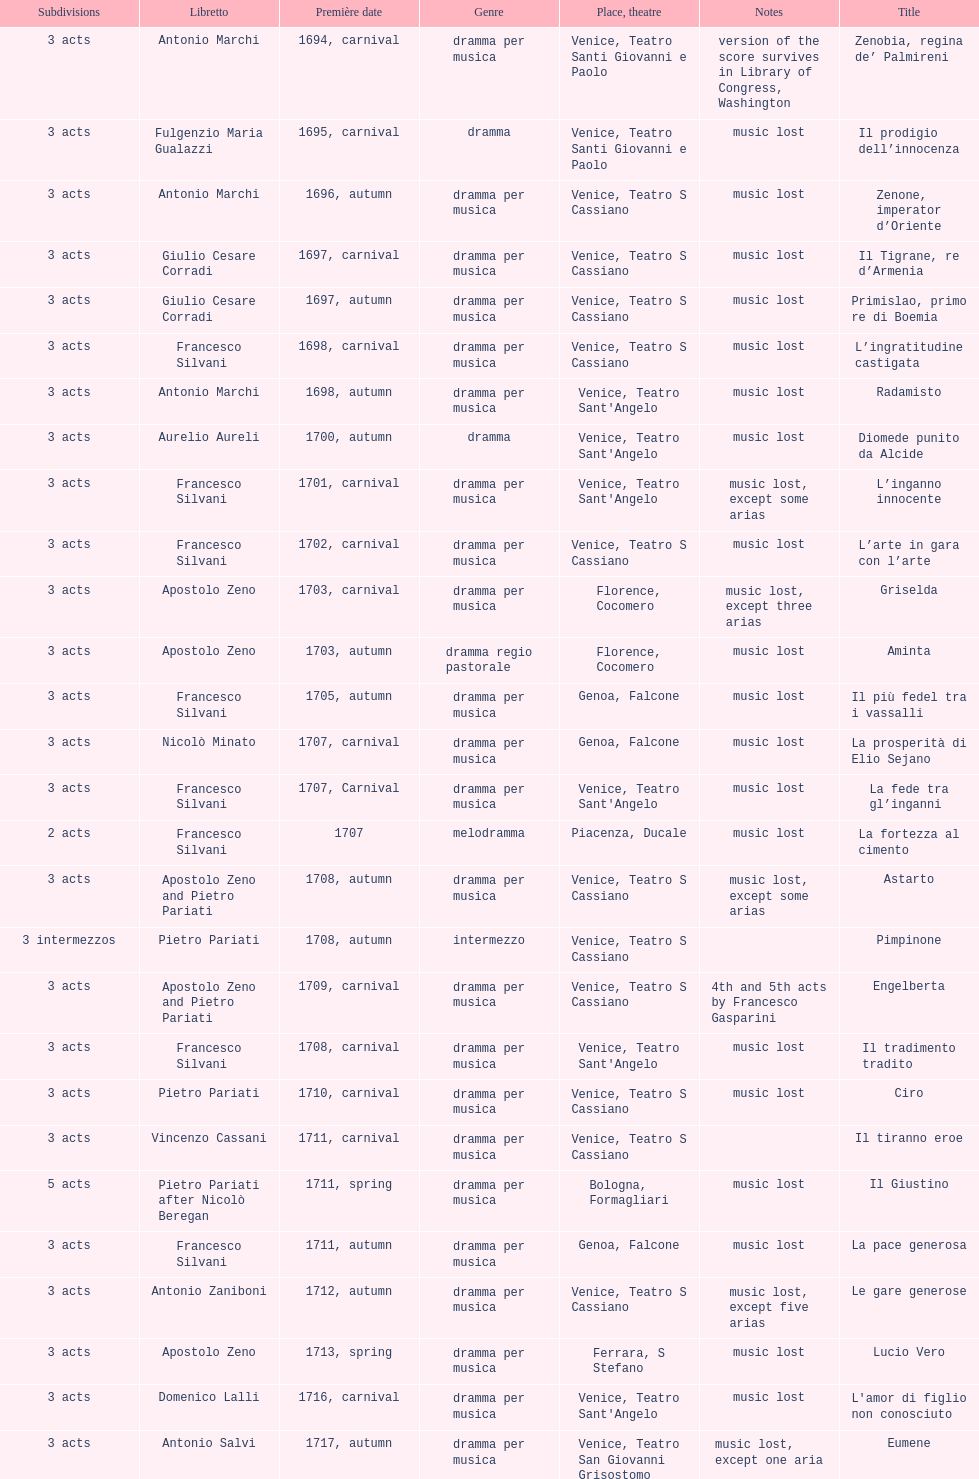What number of acts does il giustino have? 5. Could you parse the entire table as a dict? {'header': ['Sub\xaddivisions', 'Libretto', 'Première date', 'Genre', 'Place, theatre', 'Notes', 'Title'], 'rows': [['3 acts', 'Antonio Marchi', '1694, carnival', 'dramma per musica', 'Venice, Teatro Santi Giovanni e Paolo', 'version of the score survives in Library of Congress, Washington', 'Zenobia, regina de’ Palmireni'], ['3 acts', 'Fulgenzio Maria Gualazzi', '1695, carnival', 'dramma', 'Venice, Teatro Santi Giovanni e Paolo', 'music lost', 'Il prodigio dell’innocenza'], ['3 acts', 'Antonio Marchi', '1696, autumn', 'dramma per musica', 'Venice, Teatro S Cassiano', 'music lost', 'Zenone, imperator d’Oriente'], ['3 acts', 'Giulio Cesare Corradi', '1697, carnival', 'dramma per musica', 'Venice, Teatro S Cassiano', 'music lost', 'Il Tigrane, re d’Armenia'], ['3 acts', 'Giulio Cesare Corradi', '1697, autumn', 'dramma per musica', 'Venice, Teatro S Cassiano', 'music lost', 'Primislao, primo re di Boemia'], ['3 acts', 'Francesco Silvani', '1698, carnival', 'dramma per musica', 'Venice, Teatro S Cassiano', 'music lost', 'L’ingratitudine castigata'], ['3 acts', 'Antonio Marchi', '1698, autumn', 'dramma per musica', "Venice, Teatro Sant'Angelo", 'music lost', 'Radamisto'], ['3 acts', 'Aurelio Aureli', '1700, autumn', 'dramma', "Venice, Teatro Sant'Angelo", 'music lost', 'Diomede punito da Alcide'], ['3 acts', 'Francesco Silvani', '1701, carnival', 'dramma per musica', "Venice, Teatro Sant'Angelo", 'music lost, except some arias', 'L’inganno innocente'], ['3 acts', 'Francesco Silvani', '1702, carnival', 'dramma per musica', 'Venice, Teatro S Cassiano', 'music lost', 'L’arte in gara con l’arte'], ['3 acts', 'Apostolo Zeno', '1703, carnival', 'dramma per musica', 'Florence, Cocomero', 'music lost, except three arias', 'Griselda'], ['3 acts', 'Apostolo Zeno', '1703, autumn', 'dramma regio pastorale', 'Florence, Cocomero', 'music lost', 'Aminta'], ['3 acts', 'Francesco Silvani', '1705, autumn', 'dramma per musica', 'Genoa, Falcone', 'music lost', 'Il più fedel tra i vassalli'], ['3 acts', 'Nicolò Minato', '1707, carnival', 'dramma per musica', 'Genoa, Falcone', 'music lost', 'La prosperità di Elio Sejano'], ['3 acts', 'Francesco Silvani', '1707, Carnival', 'dramma per musica', "Venice, Teatro Sant'Angelo", 'music lost', 'La fede tra gl’inganni'], ['2 acts', 'Francesco Silvani', '1707', 'melodramma', 'Piacenza, Ducale', 'music lost', 'La fortezza al cimento'], ['3 acts', 'Apostolo Zeno and Pietro Pariati', '1708, autumn', 'dramma per musica', 'Venice, Teatro S Cassiano', 'music lost, except some arias', 'Astarto'], ['3 intermezzos', 'Pietro Pariati', '1708, autumn', 'intermezzo', 'Venice, Teatro S Cassiano', '', 'Pimpinone'], ['3 acts', 'Apostolo Zeno and Pietro Pariati', '1709, carnival', 'dramma per musica', 'Venice, Teatro S Cassiano', '4th and 5th acts by Francesco Gasparini', 'Engelberta'], ['3 acts', 'Francesco Silvani', '1708, carnival', 'dramma per musica', "Venice, Teatro Sant'Angelo", 'music lost', 'Il tradimento tradito'], ['3 acts', 'Pietro Pariati', '1710, carnival', 'dramma per musica', 'Venice, Teatro S Cassiano', 'music lost', 'Ciro'], ['3 acts', 'Vincenzo Cassani', '1711, carnival', 'dramma per musica', 'Venice, Teatro S Cassiano', '', 'Il tiranno eroe'], ['5 acts', 'Pietro Pariati after Nicolò Beregan', '1711, spring', 'dramma per musica', 'Bologna, Formagliari', 'music lost', 'Il Giustino'], ['3 acts', 'Francesco Silvani', '1711, autumn', 'dramma per musica', 'Genoa, Falcone', 'music lost', 'La pace generosa'], ['3 acts', 'Antonio Zaniboni', '1712, autumn', 'dramma per musica', 'Venice, Teatro S Cassiano', 'music lost, except five arias', 'Le gare generose'], ['3 acts', 'Apostolo Zeno', '1713, spring', 'dramma per musica', 'Ferrara, S Stefano', 'music lost', 'Lucio Vero'], ['3 acts', 'Domenico Lalli', '1716, carnival', 'dramma per musica', "Venice, Teatro Sant'Angelo", 'music lost', "L'amor di figlio non conosciuto"], ['3 acts', 'Antonio Salvi', '1717, autumn', 'dramma per musica', 'Venice, Teatro San Giovanni Grisostomo', 'music lost, except one aria', 'Eumene'], ['3 acts', 'Pietro Antonio Bernardoni', '1718, carnival', 'dramma per musica', "Venice, Teatro Sant'Angelo", 'music lost', 'Meleagro'], ['3 acts', 'Vincenzo Cassani', '1718, carnival', 'dramma per musica', "Venice, Teatro Sant'Angelo", 'music lost', 'Cleomene'], ['3 acts', 'Domenico Lalli', '1722, carnival', 'dramma per musica', "Venice, Teatro Sant'Angelo", 'music lost, except some arias', 'Gli eccessi della gelosia'], ['3 acts', 'Francesco Silvani and Domenico Lalli after Pierre Corneille', '1722, October', 'dramma per musica', 'Munich, Hof', 'music lost, except some arias', 'I veri amici'], ['3 acts', 'Pietro Pariati', '1722, November', 'dramma per musica', 'Munich', 'music lost', 'Il trionfo d’amore'], ['3 acts', 'Apostolo Zeno', '1723, carnival', 'dramma per musica', 'Venice, Teatro San Moisè', 'music lost, except 2 arias', 'Eumene'], ['3 acts', 'Antonio Maria Lucchini', '1723, autumn', 'dramma per musica', 'Venice, Teatro San Moisè', 'music lost', 'Ermengarda'], ['5 acts', 'Giovanni Piazzon', '1724, carnival', 'tragedia', 'Venice, Teatro San Moisè', '5th act by Giovanni Porta, music lost', 'Antigono, tutore di Filippo, re di Macedonia'], ['3 acts', 'Apostolo Zeno', '1724, Ascension', 'dramma per musica', 'Venice, Teatro San Samuele', 'music lost', 'Scipione nelle Spagne'], ['3 acts', 'Angelo Schietti', '1724, autumn', 'dramma per musica', 'Venice, Teatro San Moisè', 'music lost, except 2 arias', 'Laodice'], ['3 acts', 'Metastasio', '1725, carnival', 'tragedia', 'Venice, Teatro S Cassiano', 'music lost', 'Didone abbandonata'], ['2 acts', 'Metastasio', '1725, carnival', 'intermezzo', 'Venice, Teatro S Cassiano', 'music lost', "L'impresario delle Isole Canarie"], ['3 acts', 'Antonio Marchi', '1725, autumn', 'dramma per musica', 'Venice, Teatro S Cassiano', 'music lost', 'Alcina delusa da Ruggero'], ['3 acts', 'Apostolo Zeno', '1725', 'dramma per musica', 'Brescia, Nuovo', '', 'I rivali generosi'], ['3 acts', 'Apostolo Zeno and Pietro Pariati', '1726, Carnival', 'dramma per musica', 'Rome, Teatro Capranica', '', 'La Statira'], ['', '', '1726, Carnival', 'intermezzo', 'Rome, Teatro Capranica', '', 'Malsazio e Fiammetta'], ['3 acts', 'Girolamo Colatelli after Torquato Tasso', '1726, autumn', 'dramma per musica', 'Venice, Teatro San Moisè', 'music lost', 'Il trionfo di Armida'], ['3 acts', 'Vincenzo Cassani', '1727, Ascension', 'dramma comico-pastorale', 'Venice, Teatro San Samuele', 'music lost, except some arias', 'L’incostanza schernita'], ['3 acts', 'Aurelio Aureli', '1728, autumn', 'dramma per musica', 'Venice, Teatro San Moisè', 'music lost', 'Le due rivali in amore'], ['', 'Salvi', '1729', 'intermezzo', 'Parma, Omodeo', '', 'Il Satrapone'], ['3 acts', 'F Passerini', '1730, carnival', 'dramma per musica', 'Venice, Teatro San Moisè', 'music lost', 'Li stratagemmi amorosi'], ['3 acts', 'Luisa Bergalli', '1730, carnival', 'dramma per musica', "Venice, Teatro Sant'Angelo", 'music lost', 'Elenia'], ['3 acts', 'Apostolo Zeno', '1731, autumn', 'dramma', 'Prague, Sporck Theater', 'mostly by Albinoni, music lost', 'Merope'], ['3 acts', 'Angelo Schietti', '1731, autumn', 'dramma per musica', 'Treviso, Dolphin', 'music lost', 'Il più infedel tra gli amanti'], ['3 acts', 'Bartolomeo Vitturi', '1732, autumn', 'dramma', "Venice, Teatro Sant'Angelo", 'music lost, except five arias', 'Ardelinda'], ['3 acts', 'Bartolomeo Vitturi', '1734, carnival', 'dramma per musica', "Venice, Teatro Sant'Angelo", 'music lost', 'Candalide'], ['3 acts', 'Bartolomeo Vitturi', '1741, carnival', 'dramma per musica', "Venice, Teatro Sant'Angelo", 'music lost', 'Artamene']]} 